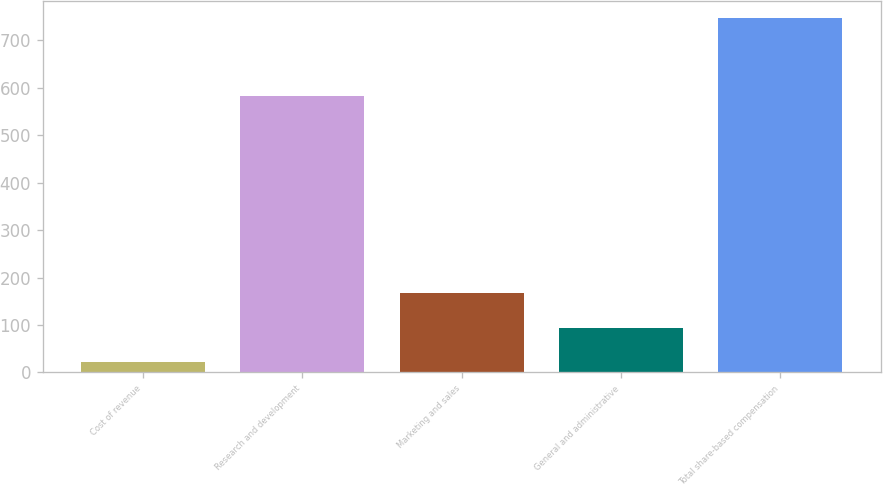<chart> <loc_0><loc_0><loc_500><loc_500><bar_chart><fcel>Cost of revenue<fcel>Research and development<fcel>Marketing and sales<fcel>General and administrative<fcel>Total share-based compensation<nl><fcel>22<fcel>583<fcel>166.8<fcel>94.4<fcel>746<nl></chart> 